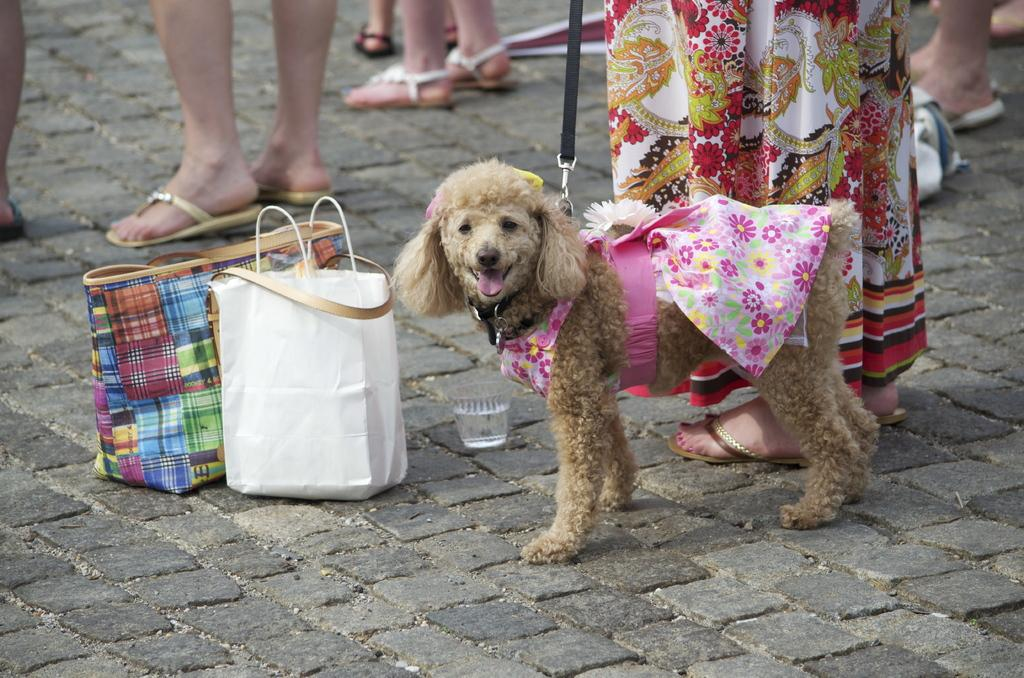What animal is present in the image? There is a dog in the image. What is the dog doing in the image? The dog is looking at the camera. Who is the dog standing beside in the image? The dog is standing beside a woman. How many brothers does the dog have in the image? There is no mention of any brothers in the image, as it only features a dog and a woman. 